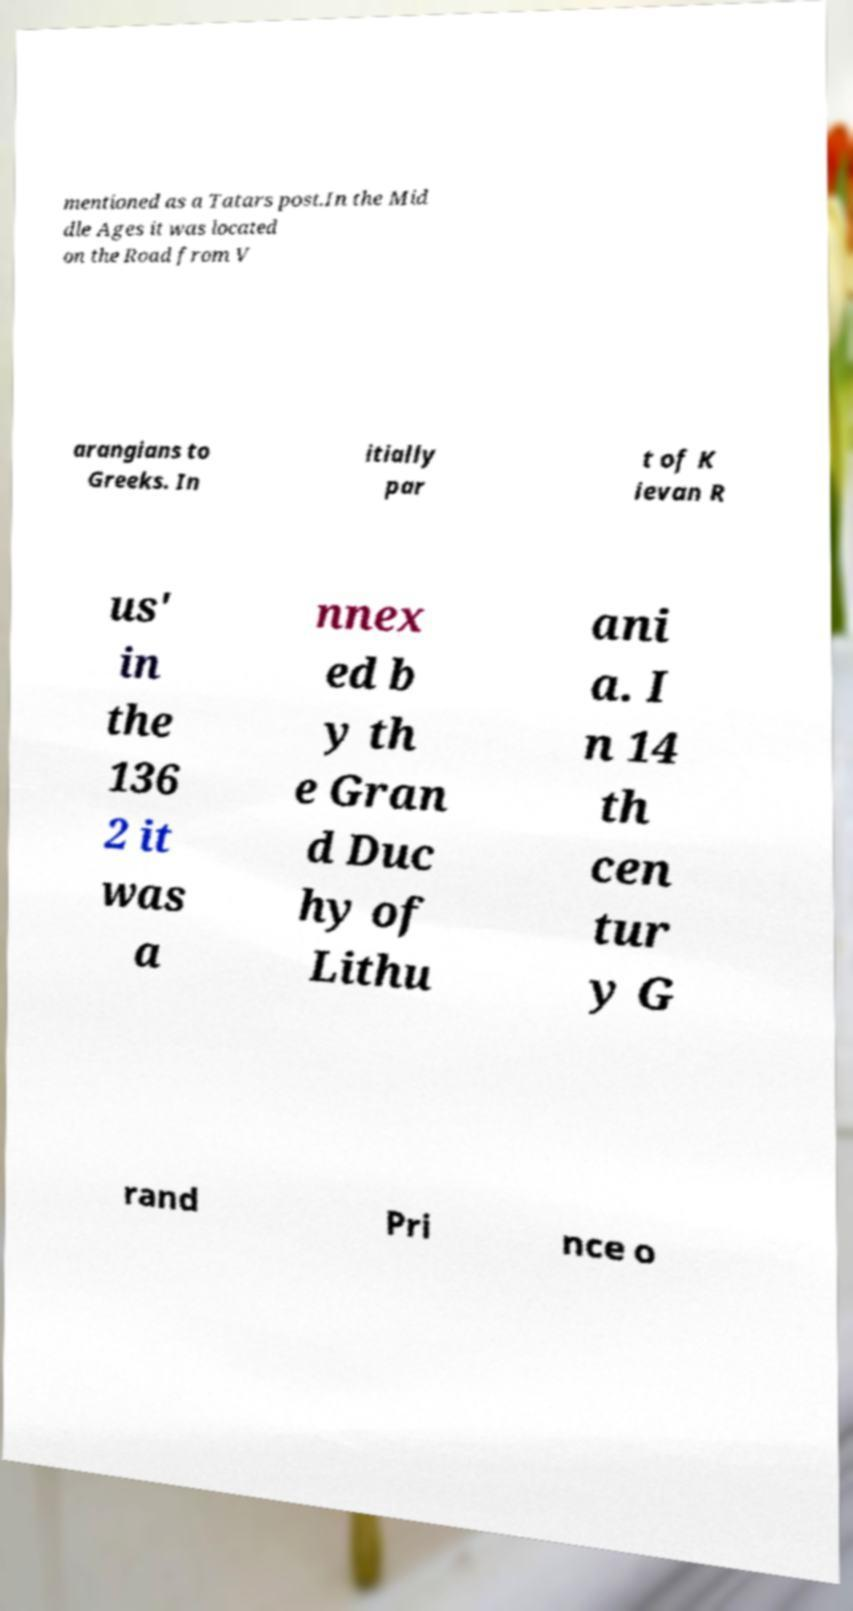Could you assist in decoding the text presented in this image and type it out clearly? mentioned as a Tatars post.In the Mid dle Ages it was located on the Road from V arangians to Greeks. In itially par t of K ievan R us' in the 136 2 it was a nnex ed b y th e Gran d Duc hy of Lithu ani a. I n 14 th cen tur y G rand Pri nce o 